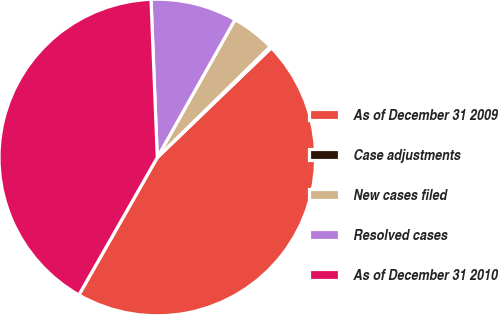Convert chart to OTSL. <chart><loc_0><loc_0><loc_500><loc_500><pie_chart><fcel>As of December 31 2009<fcel>Case adjustments<fcel>New cases filed<fcel>Resolved cases<fcel>As of December 31 2010<nl><fcel>45.44%<fcel>0.16%<fcel>4.48%<fcel>8.8%<fcel>41.12%<nl></chart> 